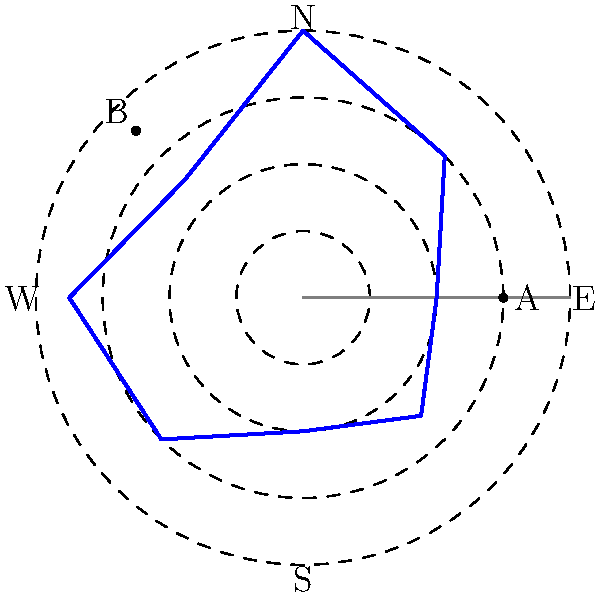In the polar coordinate system shown, which represents the orientation of ancient temples relative to celestial bodies, two temples are marked as points A and B. If the angular coordinate represents the direction from true North and the radial coordinate represents the importance of the celestial body in the temple's alignment (with larger values indicating greater importance), what is the difference in angular orientation between temples A and B? To solve this problem, we need to follow these steps:

1) First, identify the angular coordinates of temples A and B:
   - Temple A is located on the positive x-axis, which corresponds to East. In the polar coordinate system, East is at 90°.
   - Temple B is located in the third quadrant, at approximately 225° (South-West).

2) Calculate the difference between these angles:
   $225° - 90° = 135°$

3) However, in circular measurements, we always consider the smaller angle between two directions. The smaller angle would be in the opposite direction:
   $360° - 135° = 225°$

4) Therefore, the smaller angle between the two temples is:
   $360° - 225° = 135°$

This 135° difference represents the shortest angular distance between the orientations of temples A and B, regardless of clockwise or counterclockwise direction.
Answer: 135° 